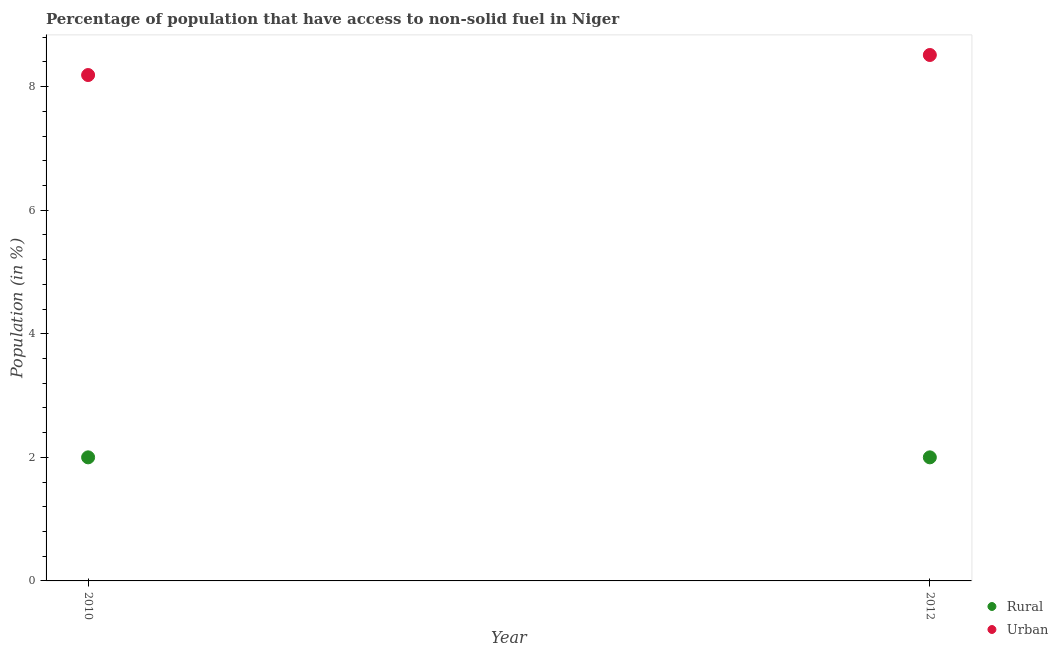What is the urban population in 2010?
Your answer should be compact. 8.19. Across all years, what is the maximum rural population?
Your answer should be very brief. 2. Across all years, what is the minimum rural population?
Provide a succinct answer. 2. In which year was the urban population minimum?
Your answer should be compact. 2010. What is the total rural population in the graph?
Make the answer very short. 4. What is the difference between the urban population in 2010 and that in 2012?
Your response must be concise. -0.32. What is the difference between the urban population in 2010 and the rural population in 2012?
Make the answer very short. 6.19. What is the average rural population per year?
Give a very brief answer. 2. In the year 2010, what is the difference between the rural population and urban population?
Offer a very short reply. -6.19. In how many years, is the urban population greater than 0.4 %?
Offer a terse response. 2. Is the urban population in 2010 less than that in 2012?
Offer a very short reply. Yes. How many years are there in the graph?
Your answer should be compact. 2. Does the graph contain any zero values?
Offer a very short reply. No. Where does the legend appear in the graph?
Provide a short and direct response. Bottom right. How are the legend labels stacked?
Provide a short and direct response. Vertical. What is the title of the graph?
Make the answer very short. Percentage of population that have access to non-solid fuel in Niger. What is the label or title of the Y-axis?
Keep it short and to the point. Population (in %). What is the Population (in %) in Rural in 2010?
Provide a short and direct response. 2. What is the Population (in %) of Urban in 2010?
Offer a terse response. 8.19. What is the Population (in %) in Rural in 2012?
Your response must be concise. 2. What is the Population (in %) of Urban in 2012?
Ensure brevity in your answer.  8.51. Across all years, what is the maximum Population (in %) of Rural?
Offer a terse response. 2. Across all years, what is the maximum Population (in %) of Urban?
Provide a succinct answer. 8.51. Across all years, what is the minimum Population (in %) in Rural?
Offer a very short reply. 2. Across all years, what is the minimum Population (in %) in Urban?
Provide a short and direct response. 8.19. What is the total Population (in %) in Urban in the graph?
Provide a succinct answer. 16.7. What is the difference between the Population (in %) in Urban in 2010 and that in 2012?
Keep it short and to the point. -0.32. What is the difference between the Population (in %) of Rural in 2010 and the Population (in %) of Urban in 2012?
Your response must be concise. -6.51. What is the average Population (in %) in Rural per year?
Keep it short and to the point. 2. What is the average Population (in %) of Urban per year?
Your response must be concise. 8.35. In the year 2010, what is the difference between the Population (in %) of Rural and Population (in %) of Urban?
Offer a terse response. -6.19. In the year 2012, what is the difference between the Population (in %) in Rural and Population (in %) in Urban?
Keep it short and to the point. -6.51. What is the ratio of the Population (in %) in Urban in 2010 to that in 2012?
Your answer should be very brief. 0.96. What is the difference between the highest and the second highest Population (in %) in Urban?
Provide a short and direct response. 0.32. What is the difference between the highest and the lowest Population (in %) in Urban?
Ensure brevity in your answer.  0.32. 